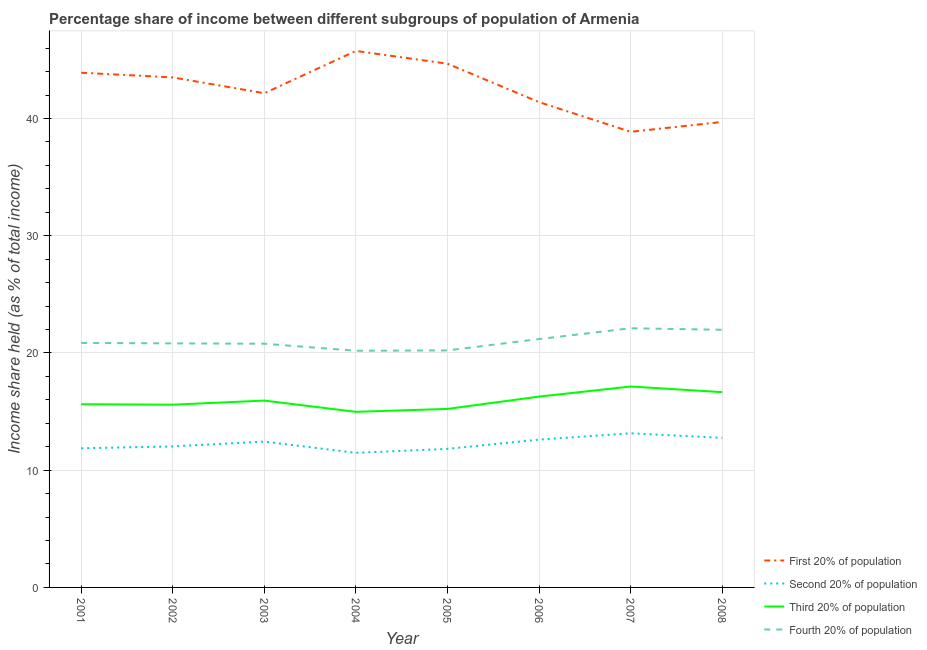How many different coloured lines are there?
Your answer should be very brief. 4. Does the line corresponding to share of the income held by fourth 20% of the population intersect with the line corresponding to share of the income held by first 20% of the population?
Ensure brevity in your answer.  No. What is the share of the income held by first 20% of the population in 2005?
Offer a very short reply. 44.68. Across all years, what is the maximum share of the income held by third 20% of the population?
Provide a succinct answer. 17.14. Across all years, what is the minimum share of the income held by third 20% of the population?
Your answer should be compact. 14.98. In which year was the share of the income held by third 20% of the population minimum?
Give a very brief answer. 2004. What is the total share of the income held by second 20% of the population in the graph?
Your response must be concise. 98.16. What is the difference between the share of the income held by first 20% of the population in 2005 and that in 2008?
Your answer should be compact. 4.97. What is the difference between the share of the income held by second 20% of the population in 2001 and the share of the income held by first 20% of the population in 2007?
Keep it short and to the point. -27. What is the average share of the income held by third 20% of the population per year?
Make the answer very short. 15.93. In the year 2003, what is the difference between the share of the income held by fourth 20% of the population and share of the income held by third 20% of the population?
Make the answer very short. 4.85. In how many years, is the share of the income held by fourth 20% of the population greater than 24 %?
Provide a succinct answer. 0. What is the ratio of the share of the income held by fourth 20% of the population in 2005 to that in 2007?
Keep it short and to the point. 0.91. What is the difference between the highest and the second highest share of the income held by fourth 20% of the population?
Provide a short and direct response. 0.13. What is the difference between the highest and the lowest share of the income held by first 20% of the population?
Offer a terse response. 6.9. In how many years, is the share of the income held by second 20% of the population greater than the average share of the income held by second 20% of the population taken over all years?
Offer a very short reply. 4. Is it the case that in every year, the sum of the share of the income held by first 20% of the population and share of the income held by second 20% of the population is greater than the share of the income held by third 20% of the population?
Offer a terse response. Yes. Does the share of the income held by third 20% of the population monotonically increase over the years?
Make the answer very short. No. Is the share of the income held by first 20% of the population strictly greater than the share of the income held by fourth 20% of the population over the years?
Ensure brevity in your answer.  Yes. Is the share of the income held by third 20% of the population strictly less than the share of the income held by first 20% of the population over the years?
Provide a short and direct response. Yes. What is the difference between two consecutive major ticks on the Y-axis?
Make the answer very short. 10. How are the legend labels stacked?
Give a very brief answer. Vertical. What is the title of the graph?
Offer a very short reply. Percentage share of income between different subgroups of population of Armenia. Does "Burnt food" appear as one of the legend labels in the graph?
Your response must be concise. No. What is the label or title of the Y-axis?
Your response must be concise. Income share held (as % of total income). What is the Income share held (as % of total income) in First 20% of population in 2001?
Keep it short and to the point. 43.91. What is the Income share held (as % of total income) in Second 20% of population in 2001?
Your answer should be very brief. 11.87. What is the Income share held (as % of total income) in Third 20% of population in 2001?
Ensure brevity in your answer.  15.63. What is the Income share held (as % of total income) of Fourth 20% of population in 2001?
Give a very brief answer. 20.86. What is the Income share held (as % of total income) of First 20% of population in 2002?
Provide a short and direct response. 43.51. What is the Income share held (as % of total income) of Second 20% of population in 2002?
Provide a short and direct response. 12.03. What is the Income share held (as % of total income) in Third 20% of population in 2002?
Your response must be concise. 15.59. What is the Income share held (as % of total income) of Fourth 20% of population in 2002?
Keep it short and to the point. 20.82. What is the Income share held (as % of total income) in First 20% of population in 2003?
Provide a short and direct response. 42.16. What is the Income share held (as % of total income) of Second 20% of population in 2003?
Offer a terse response. 12.44. What is the Income share held (as % of total income) of Third 20% of population in 2003?
Provide a succinct answer. 15.94. What is the Income share held (as % of total income) of Fourth 20% of population in 2003?
Offer a very short reply. 20.79. What is the Income share held (as % of total income) in First 20% of population in 2004?
Provide a succinct answer. 45.77. What is the Income share held (as % of total income) of Second 20% of population in 2004?
Ensure brevity in your answer.  11.48. What is the Income share held (as % of total income) of Third 20% of population in 2004?
Make the answer very short. 14.98. What is the Income share held (as % of total income) of Fourth 20% of population in 2004?
Ensure brevity in your answer.  20.19. What is the Income share held (as % of total income) in First 20% of population in 2005?
Make the answer very short. 44.68. What is the Income share held (as % of total income) in Second 20% of population in 2005?
Keep it short and to the point. 11.82. What is the Income share held (as % of total income) of Third 20% of population in 2005?
Offer a very short reply. 15.23. What is the Income share held (as % of total income) in Fourth 20% of population in 2005?
Keep it short and to the point. 20.22. What is the Income share held (as % of total income) of First 20% of population in 2006?
Your response must be concise. 41.4. What is the Income share held (as % of total income) of Second 20% of population in 2006?
Provide a succinct answer. 12.61. What is the Income share held (as % of total income) in Third 20% of population in 2006?
Your response must be concise. 16.28. What is the Income share held (as % of total income) in Fourth 20% of population in 2006?
Your answer should be very brief. 21.19. What is the Income share held (as % of total income) of First 20% of population in 2007?
Offer a very short reply. 38.87. What is the Income share held (as % of total income) of Second 20% of population in 2007?
Provide a short and direct response. 13.15. What is the Income share held (as % of total income) of Third 20% of population in 2007?
Your answer should be compact. 17.14. What is the Income share held (as % of total income) of Fourth 20% of population in 2007?
Give a very brief answer. 22.11. What is the Income share held (as % of total income) of First 20% of population in 2008?
Your answer should be compact. 39.71. What is the Income share held (as % of total income) in Second 20% of population in 2008?
Your response must be concise. 12.76. What is the Income share held (as % of total income) in Third 20% of population in 2008?
Offer a very short reply. 16.66. What is the Income share held (as % of total income) in Fourth 20% of population in 2008?
Keep it short and to the point. 21.98. Across all years, what is the maximum Income share held (as % of total income) of First 20% of population?
Your response must be concise. 45.77. Across all years, what is the maximum Income share held (as % of total income) of Second 20% of population?
Ensure brevity in your answer.  13.15. Across all years, what is the maximum Income share held (as % of total income) in Third 20% of population?
Keep it short and to the point. 17.14. Across all years, what is the maximum Income share held (as % of total income) in Fourth 20% of population?
Your response must be concise. 22.11. Across all years, what is the minimum Income share held (as % of total income) in First 20% of population?
Keep it short and to the point. 38.87. Across all years, what is the minimum Income share held (as % of total income) in Second 20% of population?
Ensure brevity in your answer.  11.48. Across all years, what is the minimum Income share held (as % of total income) in Third 20% of population?
Provide a succinct answer. 14.98. Across all years, what is the minimum Income share held (as % of total income) in Fourth 20% of population?
Provide a succinct answer. 20.19. What is the total Income share held (as % of total income) in First 20% of population in the graph?
Give a very brief answer. 340.01. What is the total Income share held (as % of total income) of Second 20% of population in the graph?
Offer a terse response. 98.16. What is the total Income share held (as % of total income) of Third 20% of population in the graph?
Make the answer very short. 127.45. What is the total Income share held (as % of total income) in Fourth 20% of population in the graph?
Your response must be concise. 168.16. What is the difference between the Income share held (as % of total income) in First 20% of population in 2001 and that in 2002?
Provide a short and direct response. 0.4. What is the difference between the Income share held (as % of total income) in Second 20% of population in 2001 and that in 2002?
Provide a short and direct response. -0.16. What is the difference between the Income share held (as % of total income) of Third 20% of population in 2001 and that in 2002?
Give a very brief answer. 0.04. What is the difference between the Income share held (as % of total income) in Second 20% of population in 2001 and that in 2003?
Keep it short and to the point. -0.57. What is the difference between the Income share held (as % of total income) in Third 20% of population in 2001 and that in 2003?
Your response must be concise. -0.31. What is the difference between the Income share held (as % of total income) of Fourth 20% of population in 2001 and that in 2003?
Ensure brevity in your answer.  0.07. What is the difference between the Income share held (as % of total income) of First 20% of population in 2001 and that in 2004?
Ensure brevity in your answer.  -1.86. What is the difference between the Income share held (as % of total income) of Second 20% of population in 2001 and that in 2004?
Your answer should be compact. 0.39. What is the difference between the Income share held (as % of total income) of Third 20% of population in 2001 and that in 2004?
Make the answer very short. 0.65. What is the difference between the Income share held (as % of total income) in Fourth 20% of population in 2001 and that in 2004?
Give a very brief answer. 0.67. What is the difference between the Income share held (as % of total income) in First 20% of population in 2001 and that in 2005?
Provide a succinct answer. -0.77. What is the difference between the Income share held (as % of total income) in Fourth 20% of population in 2001 and that in 2005?
Provide a short and direct response. 0.64. What is the difference between the Income share held (as % of total income) of First 20% of population in 2001 and that in 2006?
Offer a terse response. 2.51. What is the difference between the Income share held (as % of total income) of Second 20% of population in 2001 and that in 2006?
Provide a short and direct response. -0.74. What is the difference between the Income share held (as % of total income) of Third 20% of population in 2001 and that in 2006?
Your answer should be very brief. -0.65. What is the difference between the Income share held (as % of total income) of Fourth 20% of population in 2001 and that in 2006?
Provide a short and direct response. -0.33. What is the difference between the Income share held (as % of total income) in First 20% of population in 2001 and that in 2007?
Provide a succinct answer. 5.04. What is the difference between the Income share held (as % of total income) of Second 20% of population in 2001 and that in 2007?
Offer a terse response. -1.28. What is the difference between the Income share held (as % of total income) of Third 20% of population in 2001 and that in 2007?
Provide a short and direct response. -1.51. What is the difference between the Income share held (as % of total income) of Fourth 20% of population in 2001 and that in 2007?
Provide a short and direct response. -1.25. What is the difference between the Income share held (as % of total income) of First 20% of population in 2001 and that in 2008?
Offer a terse response. 4.2. What is the difference between the Income share held (as % of total income) of Second 20% of population in 2001 and that in 2008?
Keep it short and to the point. -0.89. What is the difference between the Income share held (as % of total income) of Third 20% of population in 2001 and that in 2008?
Give a very brief answer. -1.03. What is the difference between the Income share held (as % of total income) of Fourth 20% of population in 2001 and that in 2008?
Your response must be concise. -1.12. What is the difference between the Income share held (as % of total income) of First 20% of population in 2002 and that in 2003?
Provide a succinct answer. 1.35. What is the difference between the Income share held (as % of total income) of Second 20% of population in 2002 and that in 2003?
Your answer should be very brief. -0.41. What is the difference between the Income share held (as % of total income) of Third 20% of population in 2002 and that in 2003?
Your response must be concise. -0.35. What is the difference between the Income share held (as % of total income) of First 20% of population in 2002 and that in 2004?
Keep it short and to the point. -2.26. What is the difference between the Income share held (as % of total income) of Second 20% of population in 2002 and that in 2004?
Ensure brevity in your answer.  0.55. What is the difference between the Income share held (as % of total income) in Third 20% of population in 2002 and that in 2004?
Your answer should be very brief. 0.61. What is the difference between the Income share held (as % of total income) of Fourth 20% of population in 2002 and that in 2004?
Provide a short and direct response. 0.63. What is the difference between the Income share held (as % of total income) of First 20% of population in 2002 and that in 2005?
Your answer should be very brief. -1.17. What is the difference between the Income share held (as % of total income) in Second 20% of population in 2002 and that in 2005?
Provide a succinct answer. 0.21. What is the difference between the Income share held (as % of total income) in Third 20% of population in 2002 and that in 2005?
Your answer should be very brief. 0.36. What is the difference between the Income share held (as % of total income) of First 20% of population in 2002 and that in 2006?
Your response must be concise. 2.11. What is the difference between the Income share held (as % of total income) in Second 20% of population in 2002 and that in 2006?
Provide a short and direct response. -0.58. What is the difference between the Income share held (as % of total income) in Third 20% of population in 2002 and that in 2006?
Ensure brevity in your answer.  -0.69. What is the difference between the Income share held (as % of total income) of Fourth 20% of population in 2002 and that in 2006?
Offer a terse response. -0.37. What is the difference between the Income share held (as % of total income) of First 20% of population in 2002 and that in 2007?
Give a very brief answer. 4.64. What is the difference between the Income share held (as % of total income) in Second 20% of population in 2002 and that in 2007?
Keep it short and to the point. -1.12. What is the difference between the Income share held (as % of total income) in Third 20% of population in 2002 and that in 2007?
Your answer should be compact. -1.55. What is the difference between the Income share held (as % of total income) of Fourth 20% of population in 2002 and that in 2007?
Your response must be concise. -1.29. What is the difference between the Income share held (as % of total income) in Second 20% of population in 2002 and that in 2008?
Make the answer very short. -0.73. What is the difference between the Income share held (as % of total income) of Third 20% of population in 2002 and that in 2008?
Provide a succinct answer. -1.07. What is the difference between the Income share held (as % of total income) of Fourth 20% of population in 2002 and that in 2008?
Give a very brief answer. -1.16. What is the difference between the Income share held (as % of total income) in First 20% of population in 2003 and that in 2004?
Offer a very short reply. -3.61. What is the difference between the Income share held (as % of total income) of Second 20% of population in 2003 and that in 2004?
Give a very brief answer. 0.96. What is the difference between the Income share held (as % of total income) of Fourth 20% of population in 2003 and that in 2004?
Ensure brevity in your answer.  0.6. What is the difference between the Income share held (as % of total income) of First 20% of population in 2003 and that in 2005?
Your answer should be compact. -2.52. What is the difference between the Income share held (as % of total income) of Second 20% of population in 2003 and that in 2005?
Offer a terse response. 0.62. What is the difference between the Income share held (as % of total income) of Third 20% of population in 2003 and that in 2005?
Offer a very short reply. 0.71. What is the difference between the Income share held (as % of total income) of Fourth 20% of population in 2003 and that in 2005?
Provide a succinct answer. 0.57. What is the difference between the Income share held (as % of total income) of First 20% of population in 2003 and that in 2006?
Make the answer very short. 0.76. What is the difference between the Income share held (as % of total income) in Second 20% of population in 2003 and that in 2006?
Make the answer very short. -0.17. What is the difference between the Income share held (as % of total income) of Third 20% of population in 2003 and that in 2006?
Your answer should be compact. -0.34. What is the difference between the Income share held (as % of total income) of Fourth 20% of population in 2003 and that in 2006?
Provide a succinct answer. -0.4. What is the difference between the Income share held (as % of total income) of First 20% of population in 2003 and that in 2007?
Provide a succinct answer. 3.29. What is the difference between the Income share held (as % of total income) of Second 20% of population in 2003 and that in 2007?
Make the answer very short. -0.71. What is the difference between the Income share held (as % of total income) in Third 20% of population in 2003 and that in 2007?
Provide a short and direct response. -1.2. What is the difference between the Income share held (as % of total income) of Fourth 20% of population in 2003 and that in 2007?
Your answer should be very brief. -1.32. What is the difference between the Income share held (as % of total income) in First 20% of population in 2003 and that in 2008?
Offer a terse response. 2.45. What is the difference between the Income share held (as % of total income) of Second 20% of population in 2003 and that in 2008?
Give a very brief answer. -0.32. What is the difference between the Income share held (as % of total income) of Third 20% of population in 2003 and that in 2008?
Your response must be concise. -0.72. What is the difference between the Income share held (as % of total income) in Fourth 20% of population in 2003 and that in 2008?
Offer a terse response. -1.19. What is the difference between the Income share held (as % of total income) in First 20% of population in 2004 and that in 2005?
Provide a short and direct response. 1.09. What is the difference between the Income share held (as % of total income) in Second 20% of population in 2004 and that in 2005?
Your answer should be very brief. -0.34. What is the difference between the Income share held (as % of total income) of Third 20% of population in 2004 and that in 2005?
Provide a succinct answer. -0.25. What is the difference between the Income share held (as % of total income) in Fourth 20% of population in 2004 and that in 2005?
Offer a very short reply. -0.03. What is the difference between the Income share held (as % of total income) of First 20% of population in 2004 and that in 2006?
Provide a short and direct response. 4.37. What is the difference between the Income share held (as % of total income) of Second 20% of population in 2004 and that in 2006?
Your answer should be compact. -1.13. What is the difference between the Income share held (as % of total income) of First 20% of population in 2004 and that in 2007?
Offer a terse response. 6.9. What is the difference between the Income share held (as % of total income) of Second 20% of population in 2004 and that in 2007?
Your response must be concise. -1.67. What is the difference between the Income share held (as % of total income) in Third 20% of population in 2004 and that in 2007?
Provide a succinct answer. -2.16. What is the difference between the Income share held (as % of total income) in Fourth 20% of population in 2004 and that in 2007?
Your answer should be very brief. -1.92. What is the difference between the Income share held (as % of total income) of First 20% of population in 2004 and that in 2008?
Offer a very short reply. 6.06. What is the difference between the Income share held (as % of total income) of Second 20% of population in 2004 and that in 2008?
Your answer should be compact. -1.28. What is the difference between the Income share held (as % of total income) in Third 20% of population in 2004 and that in 2008?
Give a very brief answer. -1.68. What is the difference between the Income share held (as % of total income) in Fourth 20% of population in 2004 and that in 2008?
Offer a terse response. -1.79. What is the difference between the Income share held (as % of total income) of First 20% of population in 2005 and that in 2006?
Give a very brief answer. 3.28. What is the difference between the Income share held (as % of total income) in Second 20% of population in 2005 and that in 2006?
Give a very brief answer. -0.79. What is the difference between the Income share held (as % of total income) in Third 20% of population in 2005 and that in 2006?
Your answer should be compact. -1.05. What is the difference between the Income share held (as % of total income) of Fourth 20% of population in 2005 and that in 2006?
Keep it short and to the point. -0.97. What is the difference between the Income share held (as % of total income) of First 20% of population in 2005 and that in 2007?
Give a very brief answer. 5.81. What is the difference between the Income share held (as % of total income) of Second 20% of population in 2005 and that in 2007?
Provide a succinct answer. -1.33. What is the difference between the Income share held (as % of total income) of Third 20% of population in 2005 and that in 2007?
Provide a succinct answer. -1.91. What is the difference between the Income share held (as % of total income) of Fourth 20% of population in 2005 and that in 2007?
Your answer should be very brief. -1.89. What is the difference between the Income share held (as % of total income) of First 20% of population in 2005 and that in 2008?
Give a very brief answer. 4.97. What is the difference between the Income share held (as % of total income) of Second 20% of population in 2005 and that in 2008?
Offer a terse response. -0.94. What is the difference between the Income share held (as % of total income) in Third 20% of population in 2005 and that in 2008?
Give a very brief answer. -1.43. What is the difference between the Income share held (as % of total income) of Fourth 20% of population in 2005 and that in 2008?
Give a very brief answer. -1.76. What is the difference between the Income share held (as % of total income) in First 20% of population in 2006 and that in 2007?
Your answer should be very brief. 2.53. What is the difference between the Income share held (as % of total income) in Second 20% of population in 2006 and that in 2007?
Your response must be concise. -0.54. What is the difference between the Income share held (as % of total income) in Third 20% of population in 2006 and that in 2007?
Your response must be concise. -0.86. What is the difference between the Income share held (as % of total income) of Fourth 20% of population in 2006 and that in 2007?
Your answer should be very brief. -0.92. What is the difference between the Income share held (as % of total income) of First 20% of population in 2006 and that in 2008?
Offer a terse response. 1.69. What is the difference between the Income share held (as % of total income) of Second 20% of population in 2006 and that in 2008?
Give a very brief answer. -0.15. What is the difference between the Income share held (as % of total income) of Third 20% of population in 2006 and that in 2008?
Ensure brevity in your answer.  -0.38. What is the difference between the Income share held (as % of total income) in Fourth 20% of population in 2006 and that in 2008?
Offer a very short reply. -0.79. What is the difference between the Income share held (as % of total income) of First 20% of population in 2007 and that in 2008?
Provide a short and direct response. -0.84. What is the difference between the Income share held (as % of total income) of Second 20% of population in 2007 and that in 2008?
Your answer should be very brief. 0.39. What is the difference between the Income share held (as % of total income) of Third 20% of population in 2007 and that in 2008?
Provide a short and direct response. 0.48. What is the difference between the Income share held (as % of total income) of Fourth 20% of population in 2007 and that in 2008?
Keep it short and to the point. 0.13. What is the difference between the Income share held (as % of total income) in First 20% of population in 2001 and the Income share held (as % of total income) in Second 20% of population in 2002?
Make the answer very short. 31.88. What is the difference between the Income share held (as % of total income) in First 20% of population in 2001 and the Income share held (as % of total income) in Third 20% of population in 2002?
Offer a very short reply. 28.32. What is the difference between the Income share held (as % of total income) of First 20% of population in 2001 and the Income share held (as % of total income) of Fourth 20% of population in 2002?
Provide a short and direct response. 23.09. What is the difference between the Income share held (as % of total income) in Second 20% of population in 2001 and the Income share held (as % of total income) in Third 20% of population in 2002?
Make the answer very short. -3.72. What is the difference between the Income share held (as % of total income) of Second 20% of population in 2001 and the Income share held (as % of total income) of Fourth 20% of population in 2002?
Keep it short and to the point. -8.95. What is the difference between the Income share held (as % of total income) of Third 20% of population in 2001 and the Income share held (as % of total income) of Fourth 20% of population in 2002?
Give a very brief answer. -5.19. What is the difference between the Income share held (as % of total income) in First 20% of population in 2001 and the Income share held (as % of total income) in Second 20% of population in 2003?
Offer a very short reply. 31.47. What is the difference between the Income share held (as % of total income) of First 20% of population in 2001 and the Income share held (as % of total income) of Third 20% of population in 2003?
Keep it short and to the point. 27.97. What is the difference between the Income share held (as % of total income) in First 20% of population in 2001 and the Income share held (as % of total income) in Fourth 20% of population in 2003?
Make the answer very short. 23.12. What is the difference between the Income share held (as % of total income) in Second 20% of population in 2001 and the Income share held (as % of total income) in Third 20% of population in 2003?
Offer a terse response. -4.07. What is the difference between the Income share held (as % of total income) of Second 20% of population in 2001 and the Income share held (as % of total income) of Fourth 20% of population in 2003?
Your answer should be compact. -8.92. What is the difference between the Income share held (as % of total income) in Third 20% of population in 2001 and the Income share held (as % of total income) in Fourth 20% of population in 2003?
Your answer should be very brief. -5.16. What is the difference between the Income share held (as % of total income) in First 20% of population in 2001 and the Income share held (as % of total income) in Second 20% of population in 2004?
Your answer should be very brief. 32.43. What is the difference between the Income share held (as % of total income) of First 20% of population in 2001 and the Income share held (as % of total income) of Third 20% of population in 2004?
Give a very brief answer. 28.93. What is the difference between the Income share held (as % of total income) in First 20% of population in 2001 and the Income share held (as % of total income) in Fourth 20% of population in 2004?
Your answer should be very brief. 23.72. What is the difference between the Income share held (as % of total income) of Second 20% of population in 2001 and the Income share held (as % of total income) of Third 20% of population in 2004?
Offer a terse response. -3.11. What is the difference between the Income share held (as % of total income) of Second 20% of population in 2001 and the Income share held (as % of total income) of Fourth 20% of population in 2004?
Provide a succinct answer. -8.32. What is the difference between the Income share held (as % of total income) in Third 20% of population in 2001 and the Income share held (as % of total income) in Fourth 20% of population in 2004?
Your answer should be compact. -4.56. What is the difference between the Income share held (as % of total income) of First 20% of population in 2001 and the Income share held (as % of total income) of Second 20% of population in 2005?
Provide a short and direct response. 32.09. What is the difference between the Income share held (as % of total income) of First 20% of population in 2001 and the Income share held (as % of total income) of Third 20% of population in 2005?
Make the answer very short. 28.68. What is the difference between the Income share held (as % of total income) in First 20% of population in 2001 and the Income share held (as % of total income) in Fourth 20% of population in 2005?
Your answer should be compact. 23.69. What is the difference between the Income share held (as % of total income) in Second 20% of population in 2001 and the Income share held (as % of total income) in Third 20% of population in 2005?
Ensure brevity in your answer.  -3.36. What is the difference between the Income share held (as % of total income) of Second 20% of population in 2001 and the Income share held (as % of total income) of Fourth 20% of population in 2005?
Your answer should be compact. -8.35. What is the difference between the Income share held (as % of total income) of Third 20% of population in 2001 and the Income share held (as % of total income) of Fourth 20% of population in 2005?
Provide a short and direct response. -4.59. What is the difference between the Income share held (as % of total income) of First 20% of population in 2001 and the Income share held (as % of total income) of Second 20% of population in 2006?
Offer a very short reply. 31.3. What is the difference between the Income share held (as % of total income) of First 20% of population in 2001 and the Income share held (as % of total income) of Third 20% of population in 2006?
Give a very brief answer. 27.63. What is the difference between the Income share held (as % of total income) in First 20% of population in 2001 and the Income share held (as % of total income) in Fourth 20% of population in 2006?
Provide a short and direct response. 22.72. What is the difference between the Income share held (as % of total income) of Second 20% of population in 2001 and the Income share held (as % of total income) of Third 20% of population in 2006?
Keep it short and to the point. -4.41. What is the difference between the Income share held (as % of total income) of Second 20% of population in 2001 and the Income share held (as % of total income) of Fourth 20% of population in 2006?
Your answer should be compact. -9.32. What is the difference between the Income share held (as % of total income) of Third 20% of population in 2001 and the Income share held (as % of total income) of Fourth 20% of population in 2006?
Give a very brief answer. -5.56. What is the difference between the Income share held (as % of total income) of First 20% of population in 2001 and the Income share held (as % of total income) of Second 20% of population in 2007?
Keep it short and to the point. 30.76. What is the difference between the Income share held (as % of total income) of First 20% of population in 2001 and the Income share held (as % of total income) of Third 20% of population in 2007?
Make the answer very short. 26.77. What is the difference between the Income share held (as % of total income) of First 20% of population in 2001 and the Income share held (as % of total income) of Fourth 20% of population in 2007?
Provide a short and direct response. 21.8. What is the difference between the Income share held (as % of total income) in Second 20% of population in 2001 and the Income share held (as % of total income) in Third 20% of population in 2007?
Make the answer very short. -5.27. What is the difference between the Income share held (as % of total income) in Second 20% of population in 2001 and the Income share held (as % of total income) in Fourth 20% of population in 2007?
Your response must be concise. -10.24. What is the difference between the Income share held (as % of total income) of Third 20% of population in 2001 and the Income share held (as % of total income) of Fourth 20% of population in 2007?
Provide a short and direct response. -6.48. What is the difference between the Income share held (as % of total income) in First 20% of population in 2001 and the Income share held (as % of total income) in Second 20% of population in 2008?
Keep it short and to the point. 31.15. What is the difference between the Income share held (as % of total income) of First 20% of population in 2001 and the Income share held (as % of total income) of Third 20% of population in 2008?
Ensure brevity in your answer.  27.25. What is the difference between the Income share held (as % of total income) of First 20% of population in 2001 and the Income share held (as % of total income) of Fourth 20% of population in 2008?
Offer a very short reply. 21.93. What is the difference between the Income share held (as % of total income) of Second 20% of population in 2001 and the Income share held (as % of total income) of Third 20% of population in 2008?
Your answer should be very brief. -4.79. What is the difference between the Income share held (as % of total income) of Second 20% of population in 2001 and the Income share held (as % of total income) of Fourth 20% of population in 2008?
Offer a very short reply. -10.11. What is the difference between the Income share held (as % of total income) of Third 20% of population in 2001 and the Income share held (as % of total income) of Fourth 20% of population in 2008?
Give a very brief answer. -6.35. What is the difference between the Income share held (as % of total income) in First 20% of population in 2002 and the Income share held (as % of total income) in Second 20% of population in 2003?
Your answer should be compact. 31.07. What is the difference between the Income share held (as % of total income) in First 20% of population in 2002 and the Income share held (as % of total income) in Third 20% of population in 2003?
Provide a succinct answer. 27.57. What is the difference between the Income share held (as % of total income) of First 20% of population in 2002 and the Income share held (as % of total income) of Fourth 20% of population in 2003?
Keep it short and to the point. 22.72. What is the difference between the Income share held (as % of total income) in Second 20% of population in 2002 and the Income share held (as % of total income) in Third 20% of population in 2003?
Make the answer very short. -3.91. What is the difference between the Income share held (as % of total income) of Second 20% of population in 2002 and the Income share held (as % of total income) of Fourth 20% of population in 2003?
Give a very brief answer. -8.76. What is the difference between the Income share held (as % of total income) in First 20% of population in 2002 and the Income share held (as % of total income) in Second 20% of population in 2004?
Provide a short and direct response. 32.03. What is the difference between the Income share held (as % of total income) of First 20% of population in 2002 and the Income share held (as % of total income) of Third 20% of population in 2004?
Give a very brief answer. 28.53. What is the difference between the Income share held (as % of total income) of First 20% of population in 2002 and the Income share held (as % of total income) of Fourth 20% of population in 2004?
Keep it short and to the point. 23.32. What is the difference between the Income share held (as % of total income) in Second 20% of population in 2002 and the Income share held (as % of total income) in Third 20% of population in 2004?
Your answer should be very brief. -2.95. What is the difference between the Income share held (as % of total income) of Second 20% of population in 2002 and the Income share held (as % of total income) of Fourth 20% of population in 2004?
Your response must be concise. -8.16. What is the difference between the Income share held (as % of total income) in First 20% of population in 2002 and the Income share held (as % of total income) in Second 20% of population in 2005?
Provide a short and direct response. 31.69. What is the difference between the Income share held (as % of total income) of First 20% of population in 2002 and the Income share held (as % of total income) of Third 20% of population in 2005?
Your response must be concise. 28.28. What is the difference between the Income share held (as % of total income) in First 20% of population in 2002 and the Income share held (as % of total income) in Fourth 20% of population in 2005?
Offer a very short reply. 23.29. What is the difference between the Income share held (as % of total income) in Second 20% of population in 2002 and the Income share held (as % of total income) in Fourth 20% of population in 2005?
Your response must be concise. -8.19. What is the difference between the Income share held (as % of total income) in Third 20% of population in 2002 and the Income share held (as % of total income) in Fourth 20% of population in 2005?
Provide a short and direct response. -4.63. What is the difference between the Income share held (as % of total income) in First 20% of population in 2002 and the Income share held (as % of total income) in Second 20% of population in 2006?
Provide a short and direct response. 30.9. What is the difference between the Income share held (as % of total income) of First 20% of population in 2002 and the Income share held (as % of total income) of Third 20% of population in 2006?
Provide a short and direct response. 27.23. What is the difference between the Income share held (as % of total income) in First 20% of population in 2002 and the Income share held (as % of total income) in Fourth 20% of population in 2006?
Your answer should be very brief. 22.32. What is the difference between the Income share held (as % of total income) of Second 20% of population in 2002 and the Income share held (as % of total income) of Third 20% of population in 2006?
Offer a terse response. -4.25. What is the difference between the Income share held (as % of total income) of Second 20% of population in 2002 and the Income share held (as % of total income) of Fourth 20% of population in 2006?
Provide a succinct answer. -9.16. What is the difference between the Income share held (as % of total income) of First 20% of population in 2002 and the Income share held (as % of total income) of Second 20% of population in 2007?
Your answer should be very brief. 30.36. What is the difference between the Income share held (as % of total income) of First 20% of population in 2002 and the Income share held (as % of total income) of Third 20% of population in 2007?
Offer a terse response. 26.37. What is the difference between the Income share held (as % of total income) in First 20% of population in 2002 and the Income share held (as % of total income) in Fourth 20% of population in 2007?
Make the answer very short. 21.4. What is the difference between the Income share held (as % of total income) of Second 20% of population in 2002 and the Income share held (as % of total income) of Third 20% of population in 2007?
Offer a very short reply. -5.11. What is the difference between the Income share held (as % of total income) of Second 20% of population in 2002 and the Income share held (as % of total income) of Fourth 20% of population in 2007?
Offer a terse response. -10.08. What is the difference between the Income share held (as % of total income) in Third 20% of population in 2002 and the Income share held (as % of total income) in Fourth 20% of population in 2007?
Give a very brief answer. -6.52. What is the difference between the Income share held (as % of total income) of First 20% of population in 2002 and the Income share held (as % of total income) of Second 20% of population in 2008?
Ensure brevity in your answer.  30.75. What is the difference between the Income share held (as % of total income) in First 20% of population in 2002 and the Income share held (as % of total income) in Third 20% of population in 2008?
Your answer should be very brief. 26.85. What is the difference between the Income share held (as % of total income) in First 20% of population in 2002 and the Income share held (as % of total income) in Fourth 20% of population in 2008?
Make the answer very short. 21.53. What is the difference between the Income share held (as % of total income) in Second 20% of population in 2002 and the Income share held (as % of total income) in Third 20% of population in 2008?
Your response must be concise. -4.63. What is the difference between the Income share held (as % of total income) of Second 20% of population in 2002 and the Income share held (as % of total income) of Fourth 20% of population in 2008?
Offer a terse response. -9.95. What is the difference between the Income share held (as % of total income) in Third 20% of population in 2002 and the Income share held (as % of total income) in Fourth 20% of population in 2008?
Your answer should be compact. -6.39. What is the difference between the Income share held (as % of total income) in First 20% of population in 2003 and the Income share held (as % of total income) in Second 20% of population in 2004?
Make the answer very short. 30.68. What is the difference between the Income share held (as % of total income) in First 20% of population in 2003 and the Income share held (as % of total income) in Third 20% of population in 2004?
Keep it short and to the point. 27.18. What is the difference between the Income share held (as % of total income) of First 20% of population in 2003 and the Income share held (as % of total income) of Fourth 20% of population in 2004?
Your answer should be very brief. 21.97. What is the difference between the Income share held (as % of total income) in Second 20% of population in 2003 and the Income share held (as % of total income) in Third 20% of population in 2004?
Provide a succinct answer. -2.54. What is the difference between the Income share held (as % of total income) of Second 20% of population in 2003 and the Income share held (as % of total income) of Fourth 20% of population in 2004?
Your response must be concise. -7.75. What is the difference between the Income share held (as % of total income) in Third 20% of population in 2003 and the Income share held (as % of total income) in Fourth 20% of population in 2004?
Give a very brief answer. -4.25. What is the difference between the Income share held (as % of total income) in First 20% of population in 2003 and the Income share held (as % of total income) in Second 20% of population in 2005?
Your answer should be compact. 30.34. What is the difference between the Income share held (as % of total income) in First 20% of population in 2003 and the Income share held (as % of total income) in Third 20% of population in 2005?
Keep it short and to the point. 26.93. What is the difference between the Income share held (as % of total income) of First 20% of population in 2003 and the Income share held (as % of total income) of Fourth 20% of population in 2005?
Give a very brief answer. 21.94. What is the difference between the Income share held (as % of total income) in Second 20% of population in 2003 and the Income share held (as % of total income) in Third 20% of population in 2005?
Give a very brief answer. -2.79. What is the difference between the Income share held (as % of total income) in Second 20% of population in 2003 and the Income share held (as % of total income) in Fourth 20% of population in 2005?
Offer a terse response. -7.78. What is the difference between the Income share held (as % of total income) of Third 20% of population in 2003 and the Income share held (as % of total income) of Fourth 20% of population in 2005?
Your answer should be very brief. -4.28. What is the difference between the Income share held (as % of total income) of First 20% of population in 2003 and the Income share held (as % of total income) of Second 20% of population in 2006?
Give a very brief answer. 29.55. What is the difference between the Income share held (as % of total income) of First 20% of population in 2003 and the Income share held (as % of total income) of Third 20% of population in 2006?
Give a very brief answer. 25.88. What is the difference between the Income share held (as % of total income) of First 20% of population in 2003 and the Income share held (as % of total income) of Fourth 20% of population in 2006?
Ensure brevity in your answer.  20.97. What is the difference between the Income share held (as % of total income) of Second 20% of population in 2003 and the Income share held (as % of total income) of Third 20% of population in 2006?
Keep it short and to the point. -3.84. What is the difference between the Income share held (as % of total income) of Second 20% of population in 2003 and the Income share held (as % of total income) of Fourth 20% of population in 2006?
Provide a succinct answer. -8.75. What is the difference between the Income share held (as % of total income) in Third 20% of population in 2003 and the Income share held (as % of total income) in Fourth 20% of population in 2006?
Offer a very short reply. -5.25. What is the difference between the Income share held (as % of total income) of First 20% of population in 2003 and the Income share held (as % of total income) of Second 20% of population in 2007?
Give a very brief answer. 29.01. What is the difference between the Income share held (as % of total income) of First 20% of population in 2003 and the Income share held (as % of total income) of Third 20% of population in 2007?
Give a very brief answer. 25.02. What is the difference between the Income share held (as % of total income) in First 20% of population in 2003 and the Income share held (as % of total income) in Fourth 20% of population in 2007?
Ensure brevity in your answer.  20.05. What is the difference between the Income share held (as % of total income) of Second 20% of population in 2003 and the Income share held (as % of total income) of Third 20% of population in 2007?
Your response must be concise. -4.7. What is the difference between the Income share held (as % of total income) in Second 20% of population in 2003 and the Income share held (as % of total income) in Fourth 20% of population in 2007?
Provide a short and direct response. -9.67. What is the difference between the Income share held (as % of total income) in Third 20% of population in 2003 and the Income share held (as % of total income) in Fourth 20% of population in 2007?
Offer a very short reply. -6.17. What is the difference between the Income share held (as % of total income) in First 20% of population in 2003 and the Income share held (as % of total income) in Second 20% of population in 2008?
Keep it short and to the point. 29.4. What is the difference between the Income share held (as % of total income) in First 20% of population in 2003 and the Income share held (as % of total income) in Third 20% of population in 2008?
Make the answer very short. 25.5. What is the difference between the Income share held (as % of total income) of First 20% of population in 2003 and the Income share held (as % of total income) of Fourth 20% of population in 2008?
Provide a short and direct response. 20.18. What is the difference between the Income share held (as % of total income) of Second 20% of population in 2003 and the Income share held (as % of total income) of Third 20% of population in 2008?
Provide a short and direct response. -4.22. What is the difference between the Income share held (as % of total income) of Second 20% of population in 2003 and the Income share held (as % of total income) of Fourth 20% of population in 2008?
Your answer should be compact. -9.54. What is the difference between the Income share held (as % of total income) of Third 20% of population in 2003 and the Income share held (as % of total income) of Fourth 20% of population in 2008?
Your answer should be very brief. -6.04. What is the difference between the Income share held (as % of total income) in First 20% of population in 2004 and the Income share held (as % of total income) in Second 20% of population in 2005?
Make the answer very short. 33.95. What is the difference between the Income share held (as % of total income) in First 20% of population in 2004 and the Income share held (as % of total income) in Third 20% of population in 2005?
Your answer should be very brief. 30.54. What is the difference between the Income share held (as % of total income) in First 20% of population in 2004 and the Income share held (as % of total income) in Fourth 20% of population in 2005?
Make the answer very short. 25.55. What is the difference between the Income share held (as % of total income) of Second 20% of population in 2004 and the Income share held (as % of total income) of Third 20% of population in 2005?
Offer a terse response. -3.75. What is the difference between the Income share held (as % of total income) of Second 20% of population in 2004 and the Income share held (as % of total income) of Fourth 20% of population in 2005?
Offer a very short reply. -8.74. What is the difference between the Income share held (as % of total income) of Third 20% of population in 2004 and the Income share held (as % of total income) of Fourth 20% of population in 2005?
Your answer should be compact. -5.24. What is the difference between the Income share held (as % of total income) of First 20% of population in 2004 and the Income share held (as % of total income) of Second 20% of population in 2006?
Your answer should be compact. 33.16. What is the difference between the Income share held (as % of total income) of First 20% of population in 2004 and the Income share held (as % of total income) of Third 20% of population in 2006?
Provide a short and direct response. 29.49. What is the difference between the Income share held (as % of total income) of First 20% of population in 2004 and the Income share held (as % of total income) of Fourth 20% of population in 2006?
Your response must be concise. 24.58. What is the difference between the Income share held (as % of total income) in Second 20% of population in 2004 and the Income share held (as % of total income) in Fourth 20% of population in 2006?
Keep it short and to the point. -9.71. What is the difference between the Income share held (as % of total income) in Third 20% of population in 2004 and the Income share held (as % of total income) in Fourth 20% of population in 2006?
Your response must be concise. -6.21. What is the difference between the Income share held (as % of total income) in First 20% of population in 2004 and the Income share held (as % of total income) in Second 20% of population in 2007?
Your answer should be very brief. 32.62. What is the difference between the Income share held (as % of total income) of First 20% of population in 2004 and the Income share held (as % of total income) of Third 20% of population in 2007?
Keep it short and to the point. 28.63. What is the difference between the Income share held (as % of total income) of First 20% of population in 2004 and the Income share held (as % of total income) of Fourth 20% of population in 2007?
Make the answer very short. 23.66. What is the difference between the Income share held (as % of total income) in Second 20% of population in 2004 and the Income share held (as % of total income) in Third 20% of population in 2007?
Keep it short and to the point. -5.66. What is the difference between the Income share held (as % of total income) of Second 20% of population in 2004 and the Income share held (as % of total income) of Fourth 20% of population in 2007?
Your answer should be compact. -10.63. What is the difference between the Income share held (as % of total income) of Third 20% of population in 2004 and the Income share held (as % of total income) of Fourth 20% of population in 2007?
Make the answer very short. -7.13. What is the difference between the Income share held (as % of total income) in First 20% of population in 2004 and the Income share held (as % of total income) in Second 20% of population in 2008?
Offer a terse response. 33.01. What is the difference between the Income share held (as % of total income) of First 20% of population in 2004 and the Income share held (as % of total income) of Third 20% of population in 2008?
Keep it short and to the point. 29.11. What is the difference between the Income share held (as % of total income) in First 20% of population in 2004 and the Income share held (as % of total income) in Fourth 20% of population in 2008?
Your response must be concise. 23.79. What is the difference between the Income share held (as % of total income) in Second 20% of population in 2004 and the Income share held (as % of total income) in Third 20% of population in 2008?
Provide a short and direct response. -5.18. What is the difference between the Income share held (as % of total income) of Second 20% of population in 2004 and the Income share held (as % of total income) of Fourth 20% of population in 2008?
Provide a succinct answer. -10.5. What is the difference between the Income share held (as % of total income) in First 20% of population in 2005 and the Income share held (as % of total income) in Second 20% of population in 2006?
Make the answer very short. 32.07. What is the difference between the Income share held (as % of total income) in First 20% of population in 2005 and the Income share held (as % of total income) in Third 20% of population in 2006?
Offer a terse response. 28.4. What is the difference between the Income share held (as % of total income) of First 20% of population in 2005 and the Income share held (as % of total income) of Fourth 20% of population in 2006?
Provide a short and direct response. 23.49. What is the difference between the Income share held (as % of total income) of Second 20% of population in 2005 and the Income share held (as % of total income) of Third 20% of population in 2006?
Provide a short and direct response. -4.46. What is the difference between the Income share held (as % of total income) of Second 20% of population in 2005 and the Income share held (as % of total income) of Fourth 20% of population in 2006?
Offer a very short reply. -9.37. What is the difference between the Income share held (as % of total income) in Third 20% of population in 2005 and the Income share held (as % of total income) in Fourth 20% of population in 2006?
Provide a succinct answer. -5.96. What is the difference between the Income share held (as % of total income) of First 20% of population in 2005 and the Income share held (as % of total income) of Second 20% of population in 2007?
Your answer should be compact. 31.53. What is the difference between the Income share held (as % of total income) of First 20% of population in 2005 and the Income share held (as % of total income) of Third 20% of population in 2007?
Provide a succinct answer. 27.54. What is the difference between the Income share held (as % of total income) of First 20% of population in 2005 and the Income share held (as % of total income) of Fourth 20% of population in 2007?
Provide a short and direct response. 22.57. What is the difference between the Income share held (as % of total income) in Second 20% of population in 2005 and the Income share held (as % of total income) in Third 20% of population in 2007?
Make the answer very short. -5.32. What is the difference between the Income share held (as % of total income) of Second 20% of population in 2005 and the Income share held (as % of total income) of Fourth 20% of population in 2007?
Give a very brief answer. -10.29. What is the difference between the Income share held (as % of total income) of Third 20% of population in 2005 and the Income share held (as % of total income) of Fourth 20% of population in 2007?
Offer a terse response. -6.88. What is the difference between the Income share held (as % of total income) of First 20% of population in 2005 and the Income share held (as % of total income) of Second 20% of population in 2008?
Provide a short and direct response. 31.92. What is the difference between the Income share held (as % of total income) in First 20% of population in 2005 and the Income share held (as % of total income) in Third 20% of population in 2008?
Offer a very short reply. 28.02. What is the difference between the Income share held (as % of total income) in First 20% of population in 2005 and the Income share held (as % of total income) in Fourth 20% of population in 2008?
Your answer should be very brief. 22.7. What is the difference between the Income share held (as % of total income) of Second 20% of population in 2005 and the Income share held (as % of total income) of Third 20% of population in 2008?
Give a very brief answer. -4.84. What is the difference between the Income share held (as % of total income) in Second 20% of population in 2005 and the Income share held (as % of total income) in Fourth 20% of population in 2008?
Ensure brevity in your answer.  -10.16. What is the difference between the Income share held (as % of total income) of Third 20% of population in 2005 and the Income share held (as % of total income) of Fourth 20% of population in 2008?
Your answer should be very brief. -6.75. What is the difference between the Income share held (as % of total income) in First 20% of population in 2006 and the Income share held (as % of total income) in Second 20% of population in 2007?
Give a very brief answer. 28.25. What is the difference between the Income share held (as % of total income) in First 20% of population in 2006 and the Income share held (as % of total income) in Third 20% of population in 2007?
Make the answer very short. 24.26. What is the difference between the Income share held (as % of total income) of First 20% of population in 2006 and the Income share held (as % of total income) of Fourth 20% of population in 2007?
Your response must be concise. 19.29. What is the difference between the Income share held (as % of total income) of Second 20% of population in 2006 and the Income share held (as % of total income) of Third 20% of population in 2007?
Offer a very short reply. -4.53. What is the difference between the Income share held (as % of total income) in Second 20% of population in 2006 and the Income share held (as % of total income) in Fourth 20% of population in 2007?
Offer a very short reply. -9.5. What is the difference between the Income share held (as % of total income) in Third 20% of population in 2006 and the Income share held (as % of total income) in Fourth 20% of population in 2007?
Offer a terse response. -5.83. What is the difference between the Income share held (as % of total income) of First 20% of population in 2006 and the Income share held (as % of total income) of Second 20% of population in 2008?
Offer a terse response. 28.64. What is the difference between the Income share held (as % of total income) of First 20% of population in 2006 and the Income share held (as % of total income) of Third 20% of population in 2008?
Offer a terse response. 24.74. What is the difference between the Income share held (as % of total income) of First 20% of population in 2006 and the Income share held (as % of total income) of Fourth 20% of population in 2008?
Offer a terse response. 19.42. What is the difference between the Income share held (as % of total income) of Second 20% of population in 2006 and the Income share held (as % of total income) of Third 20% of population in 2008?
Provide a short and direct response. -4.05. What is the difference between the Income share held (as % of total income) in Second 20% of population in 2006 and the Income share held (as % of total income) in Fourth 20% of population in 2008?
Your answer should be very brief. -9.37. What is the difference between the Income share held (as % of total income) in Third 20% of population in 2006 and the Income share held (as % of total income) in Fourth 20% of population in 2008?
Offer a very short reply. -5.7. What is the difference between the Income share held (as % of total income) of First 20% of population in 2007 and the Income share held (as % of total income) of Second 20% of population in 2008?
Make the answer very short. 26.11. What is the difference between the Income share held (as % of total income) of First 20% of population in 2007 and the Income share held (as % of total income) of Third 20% of population in 2008?
Give a very brief answer. 22.21. What is the difference between the Income share held (as % of total income) in First 20% of population in 2007 and the Income share held (as % of total income) in Fourth 20% of population in 2008?
Offer a very short reply. 16.89. What is the difference between the Income share held (as % of total income) in Second 20% of population in 2007 and the Income share held (as % of total income) in Third 20% of population in 2008?
Ensure brevity in your answer.  -3.51. What is the difference between the Income share held (as % of total income) in Second 20% of population in 2007 and the Income share held (as % of total income) in Fourth 20% of population in 2008?
Offer a very short reply. -8.83. What is the difference between the Income share held (as % of total income) of Third 20% of population in 2007 and the Income share held (as % of total income) of Fourth 20% of population in 2008?
Your response must be concise. -4.84. What is the average Income share held (as % of total income) of First 20% of population per year?
Offer a very short reply. 42.5. What is the average Income share held (as % of total income) of Second 20% of population per year?
Offer a very short reply. 12.27. What is the average Income share held (as % of total income) of Third 20% of population per year?
Offer a very short reply. 15.93. What is the average Income share held (as % of total income) in Fourth 20% of population per year?
Provide a short and direct response. 21.02. In the year 2001, what is the difference between the Income share held (as % of total income) of First 20% of population and Income share held (as % of total income) of Second 20% of population?
Offer a very short reply. 32.04. In the year 2001, what is the difference between the Income share held (as % of total income) in First 20% of population and Income share held (as % of total income) in Third 20% of population?
Give a very brief answer. 28.28. In the year 2001, what is the difference between the Income share held (as % of total income) of First 20% of population and Income share held (as % of total income) of Fourth 20% of population?
Keep it short and to the point. 23.05. In the year 2001, what is the difference between the Income share held (as % of total income) in Second 20% of population and Income share held (as % of total income) in Third 20% of population?
Your response must be concise. -3.76. In the year 2001, what is the difference between the Income share held (as % of total income) of Second 20% of population and Income share held (as % of total income) of Fourth 20% of population?
Offer a terse response. -8.99. In the year 2001, what is the difference between the Income share held (as % of total income) of Third 20% of population and Income share held (as % of total income) of Fourth 20% of population?
Your response must be concise. -5.23. In the year 2002, what is the difference between the Income share held (as % of total income) of First 20% of population and Income share held (as % of total income) of Second 20% of population?
Offer a terse response. 31.48. In the year 2002, what is the difference between the Income share held (as % of total income) of First 20% of population and Income share held (as % of total income) of Third 20% of population?
Your answer should be compact. 27.92. In the year 2002, what is the difference between the Income share held (as % of total income) of First 20% of population and Income share held (as % of total income) of Fourth 20% of population?
Your response must be concise. 22.69. In the year 2002, what is the difference between the Income share held (as % of total income) in Second 20% of population and Income share held (as % of total income) in Third 20% of population?
Give a very brief answer. -3.56. In the year 2002, what is the difference between the Income share held (as % of total income) in Second 20% of population and Income share held (as % of total income) in Fourth 20% of population?
Ensure brevity in your answer.  -8.79. In the year 2002, what is the difference between the Income share held (as % of total income) of Third 20% of population and Income share held (as % of total income) of Fourth 20% of population?
Give a very brief answer. -5.23. In the year 2003, what is the difference between the Income share held (as % of total income) in First 20% of population and Income share held (as % of total income) in Second 20% of population?
Give a very brief answer. 29.72. In the year 2003, what is the difference between the Income share held (as % of total income) of First 20% of population and Income share held (as % of total income) of Third 20% of population?
Your response must be concise. 26.22. In the year 2003, what is the difference between the Income share held (as % of total income) in First 20% of population and Income share held (as % of total income) in Fourth 20% of population?
Keep it short and to the point. 21.37. In the year 2003, what is the difference between the Income share held (as % of total income) of Second 20% of population and Income share held (as % of total income) of Third 20% of population?
Give a very brief answer. -3.5. In the year 2003, what is the difference between the Income share held (as % of total income) in Second 20% of population and Income share held (as % of total income) in Fourth 20% of population?
Provide a succinct answer. -8.35. In the year 2003, what is the difference between the Income share held (as % of total income) in Third 20% of population and Income share held (as % of total income) in Fourth 20% of population?
Provide a short and direct response. -4.85. In the year 2004, what is the difference between the Income share held (as % of total income) of First 20% of population and Income share held (as % of total income) of Second 20% of population?
Provide a succinct answer. 34.29. In the year 2004, what is the difference between the Income share held (as % of total income) of First 20% of population and Income share held (as % of total income) of Third 20% of population?
Your response must be concise. 30.79. In the year 2004, what is the difference between the Income share held (as % of total income) in First 20% of population and Income share held (as % of total income) in Fourth 20% of population?
Ensure brevity in your answer.  25.58. In the year 2004, what is the difference between the Income share held (as % of total income) in Second 20% of population and Income share held (as % of total income) in Fourth 20% of population?
Offer a very short reply. -8.71. In the year 2004, what is the difference between the Income share held (as % of total income) of Third 20% of population and Income share held (as % of total income) of Fourth 20% of population?
Your answer should be very brief. -5.21. In the year 2005, what is the difference between the Income share held (as % of total income) of First 20% of population and Income share held (as % of total income) of Second 20% of population?
Make the answer very short. 32.86. In the year 2005, what is the difference between the Income share held (as % of total income) in First 20% of population and Income share held (as % of total income) in Third 20% of population?
Provide a succinct answer. 29.45. In the year 2005, what is the difference between the Income share held (as % of total income) of First 20% of population and Income share held (as % of total income) of Fourth 20% of population?
Make the answer very short. 24.46. In the year 2005, what is the difference between the Income share held (as % of total income) in Second 20% of population and Income share held (as % of total income) in Third 20% of population?
Offer a terse response. -3.41. In the year 2005, what is the difference between the Income share held (as % of total income) of Second 20% of population and Income share held (as % of total income) of Fourth 20% of population?
Your response must be concise. -8.4. In the year 2005, what is the difference between the Income share held (as % of total income) in Third 20% of population and Income share held (as % of total income) in Fourth 20% of population?
Provide a short and direct response. -4.99. In the year 2006, what is the difference between the Income share held (as % of total income) in First 20% of population and Income share held (as % of total income) in Second 20% of population?
Keep it short and to the point. 28.79. In the year 2006, what is the difference between the Income share held (as % of total income) of First 20% of population and Income share held (as % of total income) of Third 20% of population?
Your response must be concise. 25.12. In the year 2006, what is the difference between the Income share held (as % of total income) of First 20% of population and Income share held (as % of total income) of Fourth 20% of population?
Provide a short and direct response. 20.21. In the year 2006, what is the difference between the Income share held (as % of total income) of Second 20% of population and Income share held (as % of total income) of Third 20% of population?
Your answer should be very brief. -3.67. In the year 2006, what is the difference between the Income share held (as % of total income) of Second 20% of population and Income share held (as % of total income) of Fourth 20% of population?
Offer a very short reply. -8.58. In the year 2006, what is the difference between the Income share held (as % of total income) of Third 20% of population and Income share held (as % of total income) of Fourth 20% of population?
Make the answer very short. -4.91. In the year 2007, what is the difference between the Income share held (as % of total income) in First 20% of population and Income share held (as % of total income) in Second 20% of population?
Your response must be concise. 25.72. In the year 2007, what is the difference between the Income share held (as % of total income) in First 20% of population and Income share held (as % of total income) in Third 20% of population?
Make the answer very short. 21.73. In the year 2007, what is the difference between the Income share held (as % of total income) in First 20% of population and Income share held (as % of total income) in Fourth 20% of population?
Keep it short and to the point. 16.76. In the year 2007, what is the difference between the Income share held (as % of total income) of Second 20% of population and Income share held (as % of total income) of Third 20% of population?
Your response must be concise. -3.99. In the year 2007, what is the difference between the Income share held (as % of total income) of Second 20% of population and Income share held (as % of total income) of Fourth 20% of population?
Offer a terse response. -8.96. In the year 2007, what is the difference between the Income share held (as % of total income) in Third 20% of population and Income share held (as % of total income) in Fourth 20% of population?
Offer a terse response. -4.97. In the year 2008, what is the difference between the Income share held (as % of total income) of First 20% of population and Income share held (as % of total income) of Second 20% of population?
Offer a very short reply. 26.95. In the year 2008, what is the difference between the Income share held (as % of total income) in First 20% of population and Income share held (as % of total income) in Third 20% of population?
Your answer should be very brief. 23.05. In the year 2008, what is the difference between the Income share held (as % of total income) of First 20% of population and Income share held (as % of total income) of Fourth 20% of population?
Your answer should be compact. 17.73. In the year 2008, what is the difference between the Income share held (as % of total income) in Second 20% of population and Income share held (as % of total income) in Third 20% of population?
Provide a short and direct response. -3.9. In the year 2008, what is the difference between the Income share held (as % of total income) of Second 20% of population and Income share held (as % of total income) of Fourth 20% of population?
Your response must be concise. -9.22. In the year 2008, what is the difference between the Income share held (as % of total income) in Third 20% of population and Income share held (as % of total income) in Fourth 20% of population?
Ensure brevity in your answer.  -5.32. What is the ratio of the Income share held (as % of total income) in First 20% of population in 2001 to that in 2002?
Provide a succinct answer. 1.01. What is the ratio of the Income share held (as % of total income) in Second 20% of population in 2001 to that in 2002?
Your answer should be very brief. 0.99. What is the ratio of the Income share held (as % of total income) in First 20% of population in 2001 to that in 2003?
Provide a short and direct response. 1.04. What is the ratio of the Income share held (as % of total income) of Second 20% of population in 2001 to that in 2003?
Make the answer very short. 0.95. What is the ratio of the Income share held (as % of total income) of Third 20% of population in 2001 to that in 2003?
Give a very brief answer. 0.98. What is the ratio of the Income share held (as % of total income) in Fourth 20% of population in 2001 to that in 2003?
Give a very brief answer. 1. What is the ratio of the Income share held (as % of total income) of First 20% of population in 2001 to that in 2004?
Your response must be concise. 0.96. What is the ratio of the Income share held (as % of total income) of Second 20% of population in 2001 to that in 2004?
Give a very brief answer. 1.03. What is the ratio of the Income share held (as % of total income) of Third 20% of population in 2001 to that in 2004?
Provide a succinct answer. 1.04. What is the ratio of the Income share held (as % of total income) of Fourth 20% of population in 2001 to that in 2004?
Provide a short and direct response. 1.03. What is the ratio of the Income share held (as % of total income) in First 20% of population in 2001 to that in 2005?
Your answer should be very brief. 0.98. What is the ratio of the Income share held (as % of total income) of Third 20% of population in 2001 to that in 2005?
Ensure brevity in your answer.  1.03. What is the ratio of the Income share held (as % of total income) of Fourth 20% of population in 2001 to that in 2005?
Give a very brief answer. 1.03. What is the ratio of the Income share held (as % of total income) in First 20% of population in 2001 to that in 2006?
Your answer should be compact. 1.06. What is the ratio of the Income share held (as % of total income) of Second 20% of population in 2001 to that in 2006?
Offer a very short reply. 0.94. What is the ratio of the Income share held (as % of total income) of Third 20% of population in 2001 to that in 2006?
Your answer should be very brief. 0.96. What is the ratio of the Income share held (as % of total income) of Fourth 20% of population in 2001 to that in 2006?
Offer a terse response. 0.98. What is the ratio of the Income share held (as % of total income) in First 20% of population in 2001 to that in 2007?
Provide a succinct answer. 1.13. What is the ratio of the Income share held (as % of total income) of Second 20% of population in 2001 to that in 2007?
Offer a very short reply. 0.9. What is the ratio of the Income share held (as % of total income) of Third 20% of population in 2001 to that in 2007?
Ensure brevity in your answer.  0.91. What is the ratio of the Income share held (as % of total income) of Fourth 20% of population in 2001 to that in 2007?
Provide a succinct answer. 0.94. What is the ratio of the Income share held (as % of total income) of First 20% of population in 2001 to that in 2008?
Your answer should be compact. 1.11. What is the ratio of the Income share held (as % of total income) in Second 20% of population in 2001 to that in 2008?
Offer a terse response. 0.93. What is the ratio of the Income share held (as % of total income) in Third 20% of population in 2001 to that in 2008?
Your answer should be very brief. 0.94. What is the ratio of the Income share held (as % of total income) of Fourth 20% of population in 2001 to that in 2008?
Your answer should be very brief. 0.95. What is the ratio of the Income share held (as % of total income) of First 20% of population in 2002 to that in 2003?
Make the answer very short. 1.03. What is the ratio of the Income share held (as % of total income) in Third 20% of population in 2002 to that in 2003?
Your answer should be very brief. 0.98. What is the ratio of the Income share held (as % of total income) in Fourth 20% of population in 2002 to that in 2003?
Provide a short and direct response. 1. What is the ratio of the Income share held (as % of total income) of First 20% of population in 2002 to that in 2004?
Make the answer very short. 0.95. What is the ratio of the Income share held (as % of total income) in Second 20% of population in 2002 to that in 2004?
Make the answer very short. 1.05. What is the ratio of the Income share held (as % of total income) of Third 20% of population in 2002 to that in 2004?
Provide a short and direct response. 1.04. What is the ratio of the Income share held (as % of total income) of Fourth 20% of population in 2002 to that in 2004?
Give a very brief answer. 1.03. What is the ratio of the Income share held (as % of total income) in First 20% of population in 2002 to that in 2005?
Your response must be concise. 0.97. What is the ratio of the Income share held (as % of total income) of Second 20% of population in 2002 to that in 2005?
Your answer should be compact. 1.02. What is the ratio of the Income share held (as % of total income) in Third 20% of population in 2002 to that in 2005?
Offer a terse response. 1.02. What is the ratio of the Income share held (as % of total income) in Fourth 20% of population in 2002 to that in 2005?
Provide a short and direct response. 1.03. What is the ratio of the Income share held (as % of total income) of First 20% of population in 2002 to that in 2006?
Offer a very short reply. 1.05. What is the ratio of the Income share held (as % of total income) of Second 20% of population in 2002 to that in 2006?
Ensure brevity in your answer.  0.95. What is the ratio of the Income share held (as % of total income) in Third 20% of population in 2002 to that in 2006?
Offer a terse response. 0.96. What is the ratio of the Income share held (as % of total income) of Fourth 20% of population in 2002 to that in 2006?
Your answer should be very brief. 0.98. What is the ratio of the Income share held (as % of total income) in First 20% of population in 2002 to that in 2007?
Give a very brief answer. 1.12. What is the ratio of the Income share held (as % of total income) of Second 20% of population in 2002 to that in 2007?
Ensure brevity in your answer.  0.91. What is the ratio of the Income share held (as % of total income) of Third 20% of population in 2002 to that in 2007?
Give a very brief answer. 0.91. What is the ratio of the Income share held (as % of total income) of Fourth 20% of population in 2002 to that in 2007?
Give a very brief answer. 0.94. What is the ratio of the Income share held (as % of total income) in First 20% of population in 2002 to that in 2008?
Make the answer very short. 1.1. What is the ratio of the Income share held (as % of total income) of Second 20% of population in 2002 to that in 2008?
Provide a short and direct response. 0.94. What is the ratio of the Income share held (as % of total income) in Third 20% of population in 2002 to that in 2008?
Keep it short and to the point. 0.94. What is the ratio of the Income share held (as % of total income) of Fourth 20% of population in 2002 to that in 2008?
Make the answer very short. 0.95. What is the ratio of the Income share held (as % of total income) of First 20% of population in 2003 to that in 2004?
Offer a terse response. 0.92. What is the ratio of the Income share held (as % of total income) in Second 20% of population in 2003 to that in 2004?
Ensure brevity in your answer.  1.08. What is the ratio of the Income share held (as % of total income) of Third 20% of population in 2003 to that in 2004?
Your response must be concise. 1.06. What is the ratio of the Income share held (as % of total income) in Fourth 20% of population in 2003 to that in 2004?
Ensure brevity in your answer.  1.03. What is the ratio of the Income share held (as % of total income) in First 20% of population in 2003 to that in 2005?
Your answer should be very brief. 0.94. What is the ratio of the Income share held (as % of total income) of Second 20% of population in 2003 to that in 2005?
Make the answer very short. 1.05. What is the ratio of the Income share held (as % of total income) of Third 20% of population in 2003 to that in 2005?
Ensure brevity in your answer.  1.05. What is the ratio of the Income share held (as % of total income) in Fourth 20% of population in 2003 to that in 2005?
Provide a short and direct response. 1.03. What is the ratio of the Income share held (as % of total income) in First 20% of population in 2003 to that in 2006?
Make the answer very short. 1.02. What is the ratio of the Income share held (as % of total income) in Second 20% of population in 2003 to that in 2006?
Offer a very short reply. 0.99. What is the ratio of the Income share held (as % of total income) of Third 20% of population in 2003 to that in 2006?
Provide a short and direct response. 0.98. What is the ratio of the Income share held (as % of total income) of Fourth 20% of population in 2003 to that in 2006?
Provide a short and direct response. 0.98. What is the ratio of the Income share held (as % of total income) of First 20% of population in 2003 to that in 2007?
Ensure brevity in your answer.  1.08. What is the ratio of the Income share held (as % of total income) in Second 20% of population in 2003 to that in 2007?
Provide a succinct answer. 0.95. What is the ratio of the Income share held (as % of total income) in Fourth 20% of population in 2003 to that in 2007?
Ensure brevity in your answer.  0.94. What is the ratio of the Income share held (as % of total income) in First 20% of population in 2003 to that in 2008?
Provide a short and direct response. 1.06. What is the ratio of the Income share held (as % of total income) of Second 20% of population in 2003 to that in 2008?
Ensure brevity in your answer.  0.97. What is the ratio of the Income share held (as % of total income) of Third 20% of population in 2003 to that in 2008?
Your answer should be very brief. 0.96. What is the ratio of the Income share held (as % of total income) of Fourth 20% of population in 2003 to that in 2008?
Provide a short and direct response. 0.95. What is the ratio of the Income share held (as % of total income) in First 20% of population in 2004 to that in 2005?
Your answer should be very brief. 1.02. What is the ratio of the Income share held (as % of total income) of Second 20% of population in 2004 to that in 2005?
Provide a succinct answer. 0.97. What is the ratio of the Income share held (as % of total income) of Third 20% of population in 2004 to that in 2005?
Give a very brief answer. 0.98. What is the ratio of the Income share held (as % of total income) of Fourth 20% of population in 2004 to that in 2005?
Offer a terse response. 1. What is the ratio of the Income share held (as % of total income) of First 20% of population in 2004 to that in 2006?
Keep it short and to the point. 1.11. What is the ratio of the Income share held (as % of total income) of Second 20% of population in 2004 to that in 2006?
Your answer should be very brief. 0.91. What is the ratio of the Income share held (as % of total income) in Third 20% of population in 2004 to that in 2006?
Your answer should be very brief. 0.92. What is the ratio of the Income share held (as % of total income) of Fourth 20% of population in 2004 to that in 2006?
Keep it short and to the point. 0.95. What is the ratio of the Income share held (as % of total income) in First 20% of population in 2004 to that in 2007?
Give a very brief answer. 1.18. What is the ratio of the Income share held (as % of total income) of Second 20% of population in 2004 to that in 2007?
Provide a succinct answer. 0.87. What is the ratio of the Income share held (as % of total income) in Third 20% of population in 2004 to that in 2007?
Make the answer very short. 0.87. What is the ratio of the Income share held (as % of total income) of Fourth 20% of population in 2004 to that in 2007?
Your answer should be compact. 0.91. What is the ratio of the Income share held (as % of total income) in First 20% of population in 2004 to that in 2008?
Provide a succinct answer. 1.15. What is the ratio of the Income share held (as % of total income) of Second 20% of population in 2004 to that in 2008?
Provide a short and direct response. 0.9. What is the ratio of the Income share held (as % of total income) of Third 20% of population in 2004 to that in 2008?
Provide a short and direct response. 0.9. What is the ratio of the Income share held (as % of total income) in Fourth 20% of population in 2004 to that in 2008?
Ensure brevity in your answer.  0.92. What is the ratio of the Income share held (as % of total income) of First 20% of population in 2005 to that in 2006?
Offer a very short reply. 1.08. What is the ratio of the Income share held (as % of total income) in Second 20% of population in 2005 to that in 2006?
Your answer should be compact. 0.94. What is the ratio of the Income share held (as % of total income) in Third 20% of population in 2005 to that in 2006?
Make the answer very short. 0.94. What is the ratio of the Income share held (as % of total income) of Fourth 20% of population in 2005 to that in 2006?
Offer a very short reply. 0.95. What is the ratio of the Income share held (as % of total income) of First 20% of population in 2005 to that in 2007?
Give a very brief answer. 1.15. What is the ratio of the Income share held (as % of total income) in Second 20% of population in 2005 to that in 2007?
Give a very brief answer. 0.9. What is the ratio of the Income share held (as % of total income) in Third 20% of population in 2005 to that in 2007?
Ensure brevity in your answer.  0.89. What is the ratio of the Income share held (as % of total income) of Fourth 20% of population in 2005 to that in 2007?
Offer a terse response. 0.91. What is the ratio of the Income share held (as % of total income) of First 20% of population in 2005 to that in 2008?
Provide a succinct answer. 1.13. What is the ratio of the Income share held (as % of total income) in Second 20% of population in 2005 to that in 2008?
Make the answer very short. 0.93. What is the ratio of the Income share held (as % of total income) of Third 20% of population in 2005 to that in 2008?
Keep it short and to the point. 0.91. What is the ratio of the Income share held (as % of total income) of Fourth 20% of population in 2005 to that in 2008?
Keep it short and to the point. 0.92. What is the ratio of the Income share held (as % of total income) of First 20% of population in 2006 to that in 2007?
Ensure brevity in your answer.  1.07. What is the ratio of the Income share held (as % of total income) in Second 20% of population in 2006 to that in 2007?
Ensure brevity in your answer.  0.96. What is the ratio of the Income share held (as % of total income) in Third 20% of population in 2006 to that in 2007?
Your response must be concise. 0.95. What is the ratio of the Income share held (as % of total income) of Fourth 20% of population in 2006 to that in 2007?
Keep it short and to the point. 0.96. What is the ratio of the Income share held (as % of total income) of First 20% of population in 2006 to that in 2008?
Provide a succinct answer. 1.04. What is the ratio of the Income share held (as % of total income) of Third 20% of population in 2006 to that in 2008?
Provide a short and direct response. 0.98. What is the ratio of the Income share held (as % of total income) in Fourth 20% of population in 2006 to that in 2008?
Ensure brevity in your answer.  0.96. What is the ratio of the Income share held (as % of total income) in First 20% of population in 2007 to that in 2008?
Offer a terse response. 0.98. What is the ratio of the Income share held (as % of total income) of Second 20% of population in 2007 to that in 2008?
Your response must be concise. 1.03. What is the ratio of the Income share held (as % of total income) in Third 20% of population in 2007 to that in 2008?
Your answer should be very brief. 1.03. What is the ratio of the Income share held (as % of total income) in Fourth 20% of population in 2007 to that in 2008?
Give a very brief answer. 1.01. What is the difference between the highest and the second highest Income share held (as % of total income) in First 20% of population?
Give a very brief answer. 1.09. What is the difference between the highest and the second highest Income share held (as % of total income) of Second 20% of population?
Ensure brevity in your answer.  0.39. What is the difference between the highest and the second highest Income share held (as % of total income) of Third 20% of population?
Ensure brevity in your answer.  0.48. What is the difference between the highest and the second highest Income share held (as % of total income) in Fourth 20% of population?
Make the answer very short. 0.13. What is the difference between the highest and the lowest Income share held (as % of total income) in Second 20% of population?
Provide a short and direct response. 1.67. What is the difference between the highest and the lowest Income share held (as % of total income) in Third 20% of population?
Provide a succinct answer. 2.16. What is the difference between the highest and the lowest Income share held (as % of total income) of Fourth 20% of population?
Your answer should be compact. 1.92. 